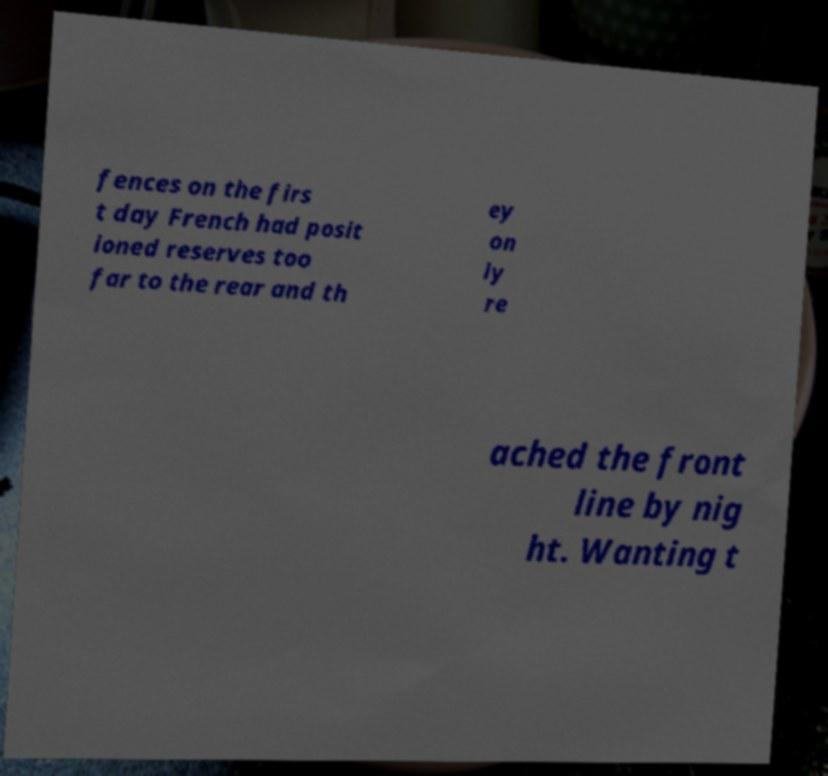I need the written content from this picture converted into text. Can you do that? fences on the firs t day French had posit ioned reserves too far to the rear and th ey on ly re ached the front line by nig ht. Wanting t 